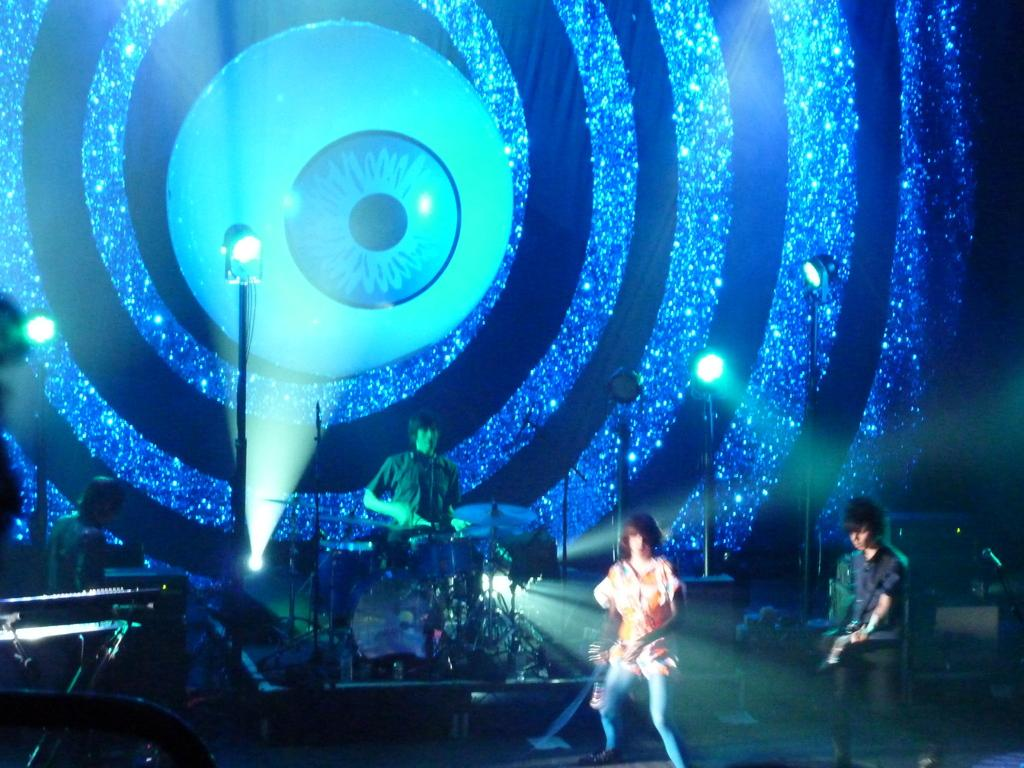What is happening on the stage in the image? There are people performing on a stage in the image. What can be seen in the background of the stage? There are poles visible in the background of the image. How does the paste help the performers on the stage in the image? There is no mention of paste in the image, so it cannot help the performers. 